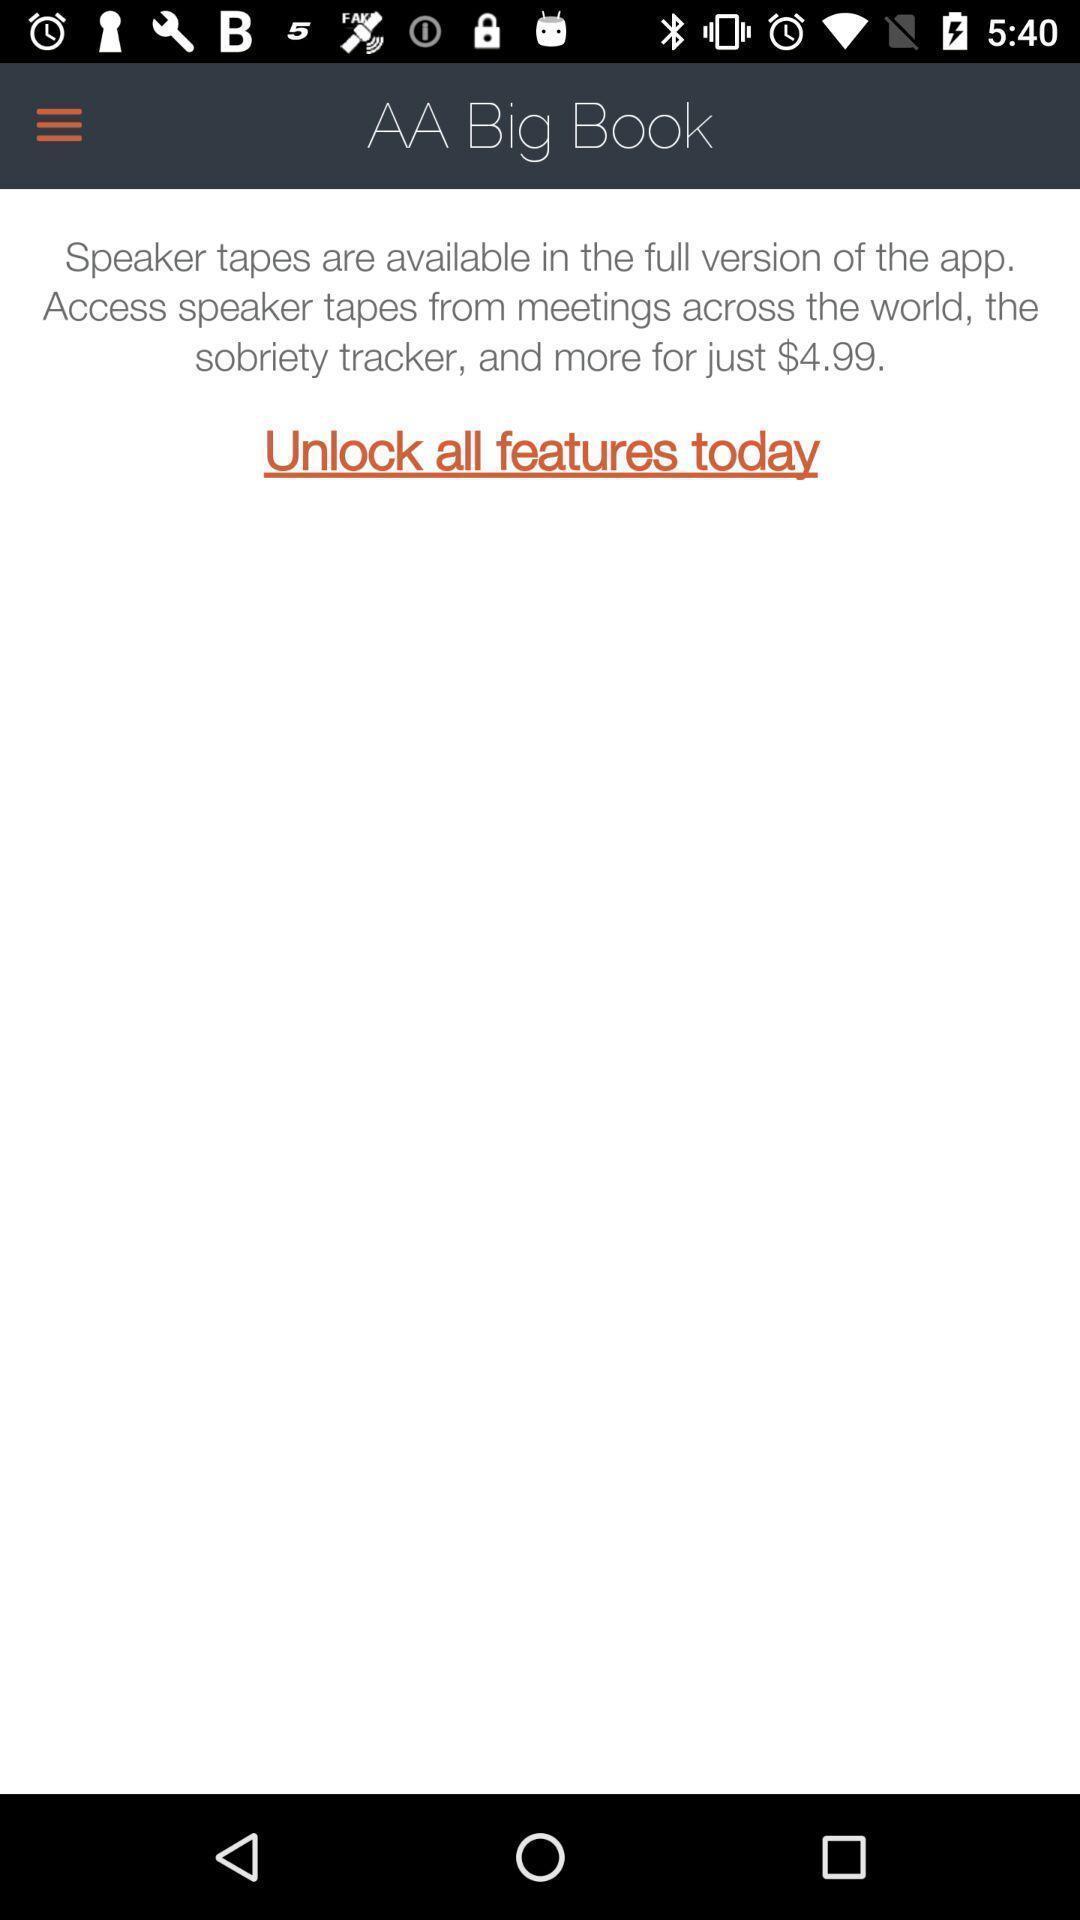What details can you identify in this image? Page showing information about unlocking the features in the app. 